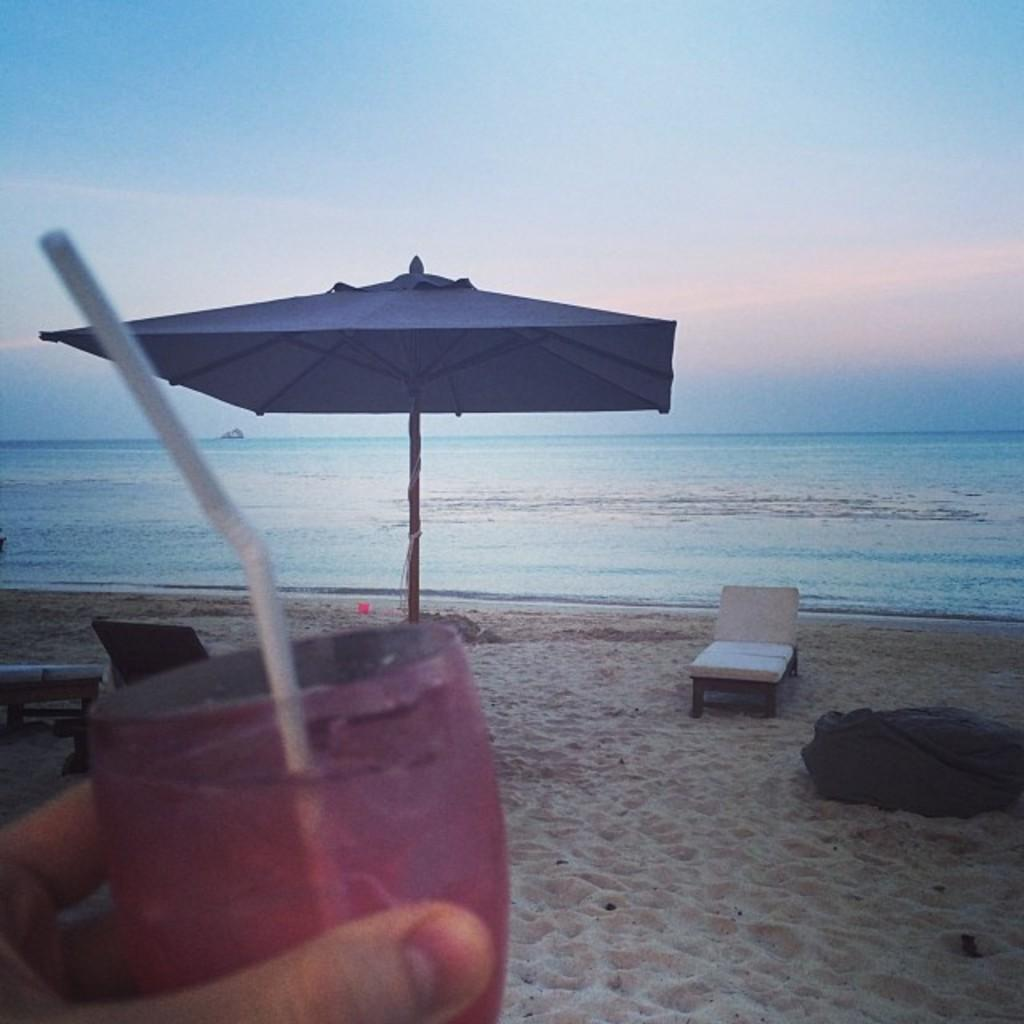What object is present in the image to provide shade? There is an umbrella in the image. What is another object in the image that suggests relaxation? There is a hammock in the image. What is the person in the image holding? There is a glass in someone's hand. What type of natural setting is visible in the image? The image contains a sea. What can be seen in the background of the image? There is a sky visible in the background of the image. How many hens are sitting on the glass in the image? There are no hens present in the image, and the glass is not being used as a perch for any birds. Can you see any cherries growing on the trees in the image? There are no trees visible in the image, so it is impossible to determine if there are any cherries growing on them. 